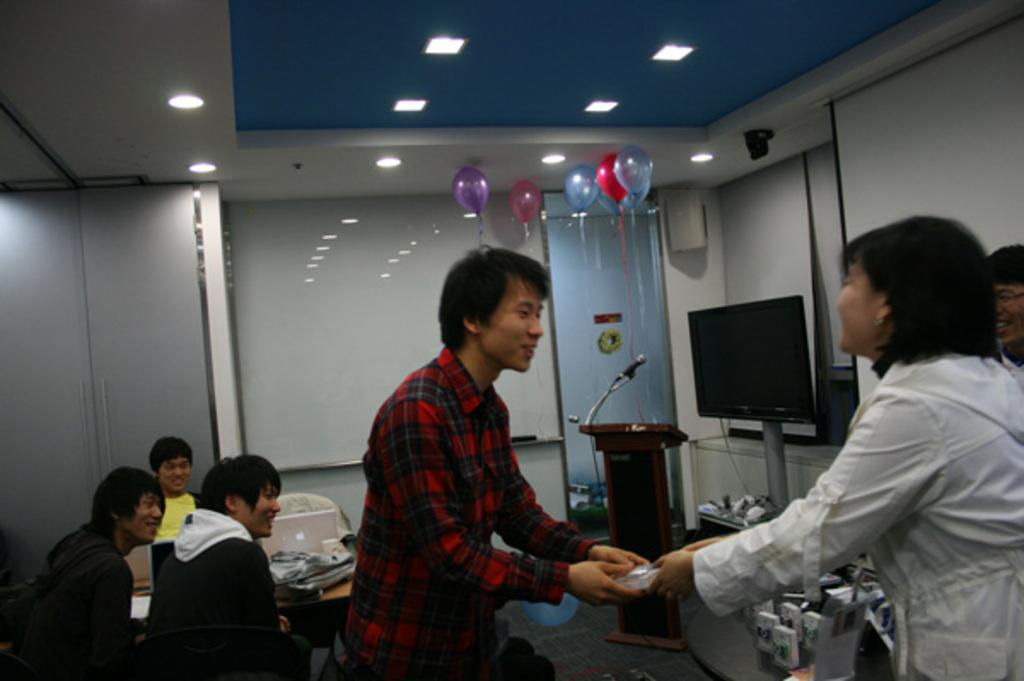How many people are in the room? There are many people in the room. What furniture is available for seating in the room? There are chairs in the room. the room. What electronic devices can be seen in the room? There are laptops in the room. What equipment is present for presentations or speeches? There is a podium with a microphone in the room. What type of display is used for visual aids? There is a projector display in the room. Are there any lights visible on the rooftop? Yes, there are lights at the rooftop. What decorative items can be seen on the rooftop? There are balloons at the rooftop. What type of polish is being applied to the suit in the image? There is no suit or polish present in the image. Can you describe the volleyball game happening in the room? There is no volleyball game present in the image. 